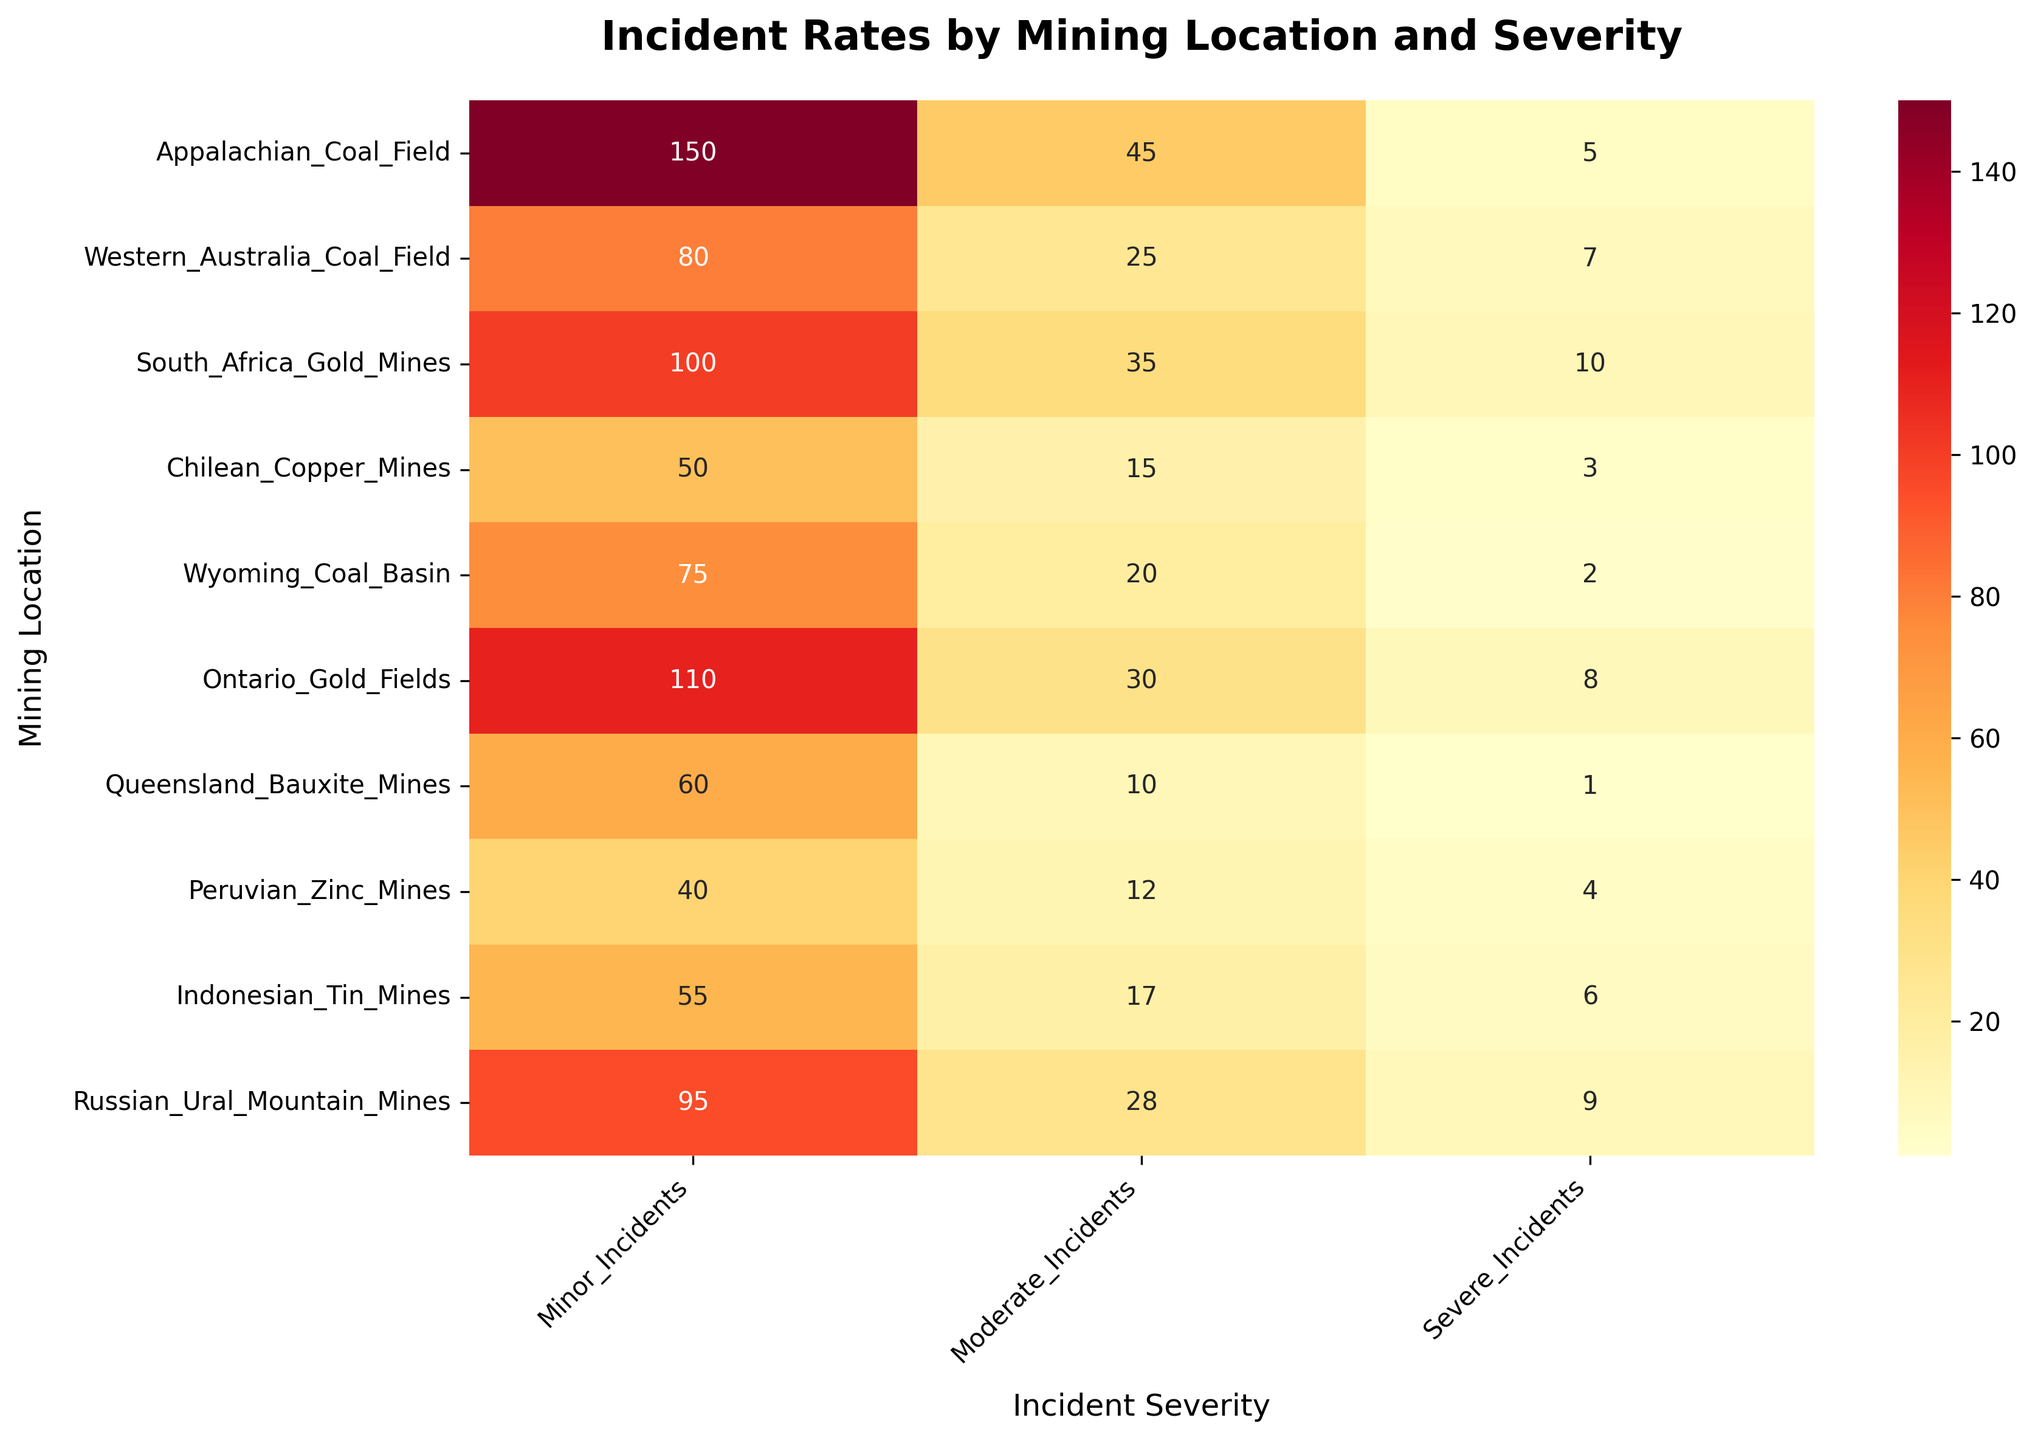What is the title of the heatmap? The title is always shown at the top of the plot. By looking at that position, you can find the text that describes the plot.
Answer: Incident Rates by Mining Location and Severity Which mining location has the highest number of severe incidents? Identify the highest value in the "Severe Incidents" column of the heatmap, and match it with the corresponding mining location on the y-axis.
Answer: South Africa Gold Mines How many minor incidents occurred in the Chilean Copper Mines? Locate "Chilean Copper Mines" on the y-axis, then read the number under the "Minor Incidents" column.
Answer: 50 Compare the number of moderate incidents between Wyoming Coal Basin and Indonesian Tin Mines. Which location had more? Identify the values of moderate incidents for both Wyoming Coal Basin and Indonesian Tin Mines and compare them.
Answer: Indonesian Tin Mines What is the average number of minor incidents across all mining locations? Add up all the values in the "Minor Incidents" column and divide by the total number of locations (10).
Answer: (150 + 80 + 100 + 50 + 75 + 110 + 60 + 40 + 55 + 95) / 10 = 81.5 Which mining location has the lowest number of total incidents (sum of minor, moderate, and severe)? Calculate the sum of minor, moderate, and severe incidents for each location and identify the location with the smallest sum.
Answer: Peruvian Zinc Mines How does the number of moderate incidents in Western Australia Coal Field compare to the number of severe incidents in the same location? Read and compare the values for moderate and severe incidents in the Western Australia Coal Field row.
Answer: Moderate incidents are higher (25 vs 7) Which severe incident count is closest to 5 among all the locations? Check the "Severe Incidents" values across all rows to find the one closest to 5.
Answer: Western Australia Coal Field What is the total number of severe incidents recorded across all mining locations? Sum the values in the "Severe Incidents" column to get the total number.
Answer: 5 + 7 + 10 + 3 + 2 + 8 + 1 + 4 + 6 + 9 = 55 